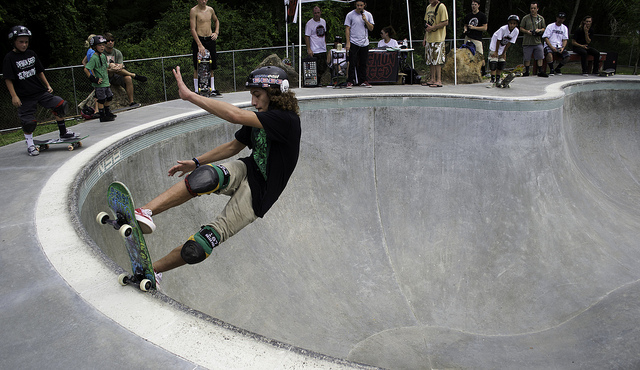How many skateboards can be seen? 1 